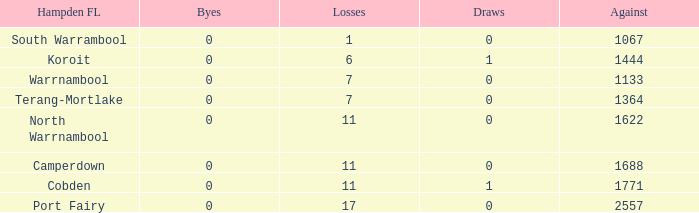What were the losses when the byes were lesser than 0? None. 